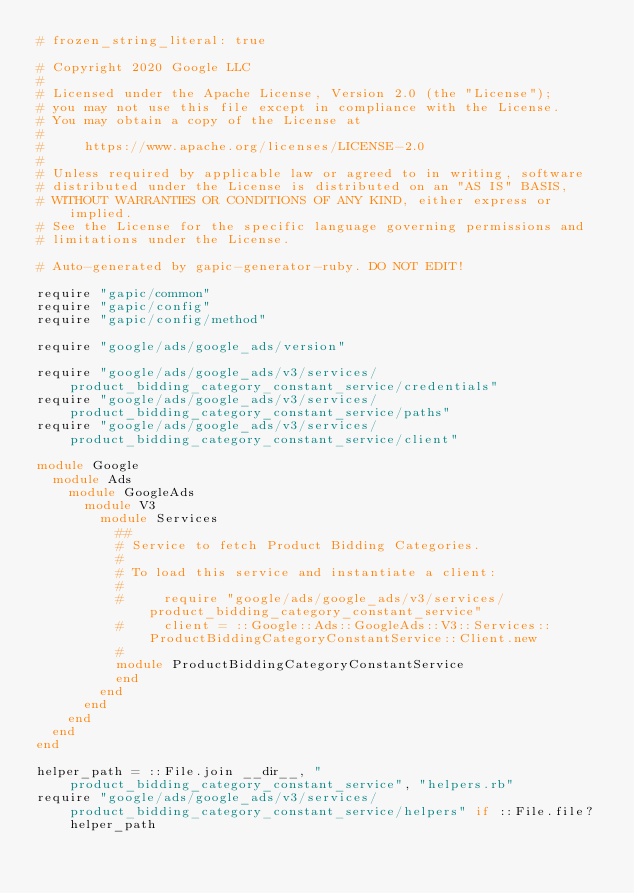<code> <loc_0><loc_0><loc_500><loc_500><_Ruby_># frozen_string_literal: true

# Copyright 2020 Google LLC
#
# Licensed under the Apache License, Version 2.0 (the "License");
# you may not use this file except in compliance with the License.
# You may obtain a copy of the License at
#
#     https://www.apache.org/licenses/LICENSE-2.0
#
# Unless required by applicable law or agreed to in writing, software
# distributed under the License is distributed on an "AS IS" BASIS,
# WITHOUT WARRANTIES OR CONDITIONS OF ANY KIND, either express or implied.
# See the License for the specific language governing permissions and
# limitations under the License.

# Auto-generated by gapic-generator-ruby. DO NOT EDIT!

require "gapic/common"
require "gapic/config"
require "gapic/config/method"

require "google/ads/google_ads/version"

require "google/ads/google_ads/v3/services/product_bidding_category_constant_service/credentials"
require "google/ads/google_ads/v3/services/product_bidding_category_constant_service/paths"
require "google/ads/google_ads/v3/services/product_bidding_category_constant_service/client"

module Google
  module Ads
    module GoogleAds
      module V3
        module Services
          ##
          # Service to fetch Product Bidding Categories.
          #
          # To load this service and instantiate a client:
          #
          #     require "google/ads/google_ads/v3/services/product_bidding_category_constant_service"
          #     client = ::Google::Ads::GoogleAds::V3::Services::ProductBiddingCategoryConstantService::Client.new
          #
          module ProductBiddingCategoryConstantService
          end
        end
      end
    end
  end
end

helper_path = ::File.join __dir__, "product_bidding_category_constant_service", "helpers.rb"
require "google/ads/google_ads/v3/services/product_bidding_category_constant_service/helpers" if ::File.file? helper_path

</code> 